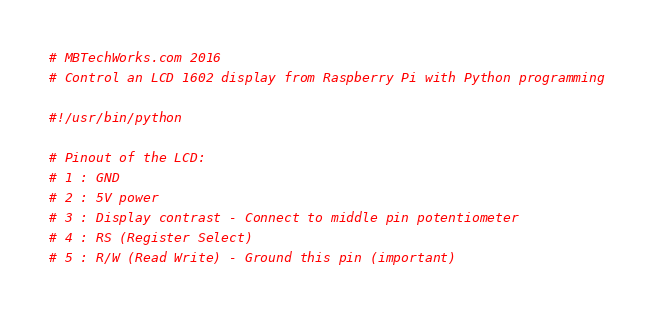Convert code to text. <code><loc_0><loc_0><loc_500><loc_500><_Python_># MBTechWorks.com 2016
# Control an LCD 1602 display from Raspberry Pi with Python programming

#!/usr/bin/python

# Pinout of the LCD:
# 1 : GND
# 2 : 5V power
# 3 : Display contrast - Connect to middle pin potentiometer 
# 4 : RS (Register Select)
# 5 : R/W (Read Write) - Ground this pin (important)</code> 